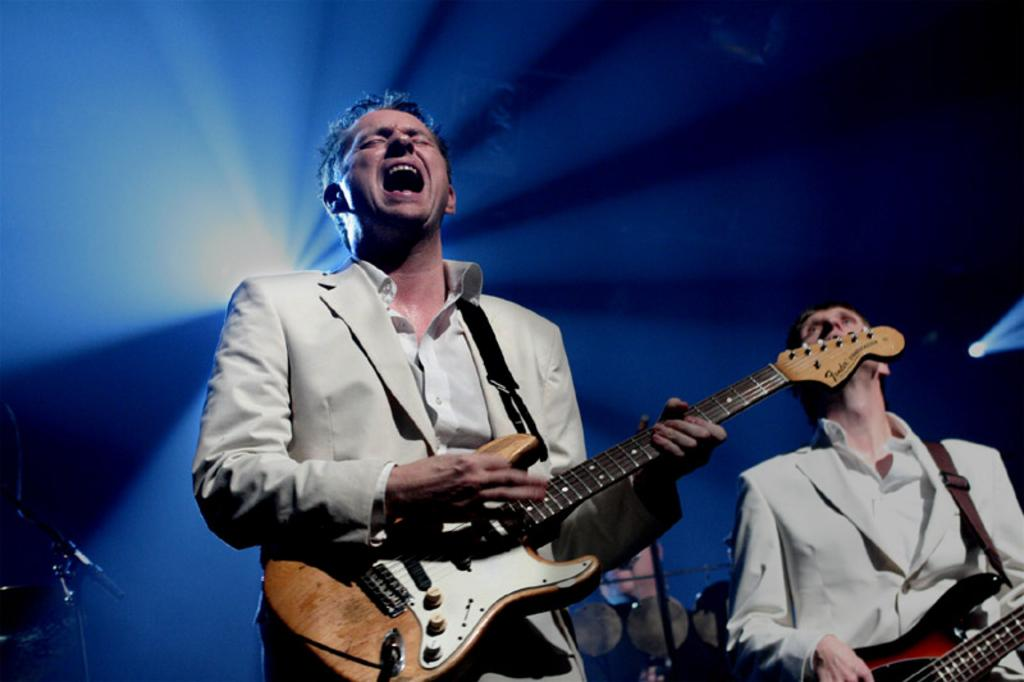What are the persons in the image doing? The persons in the image are standing and holding music instruments. What colors are the music instruments? The music instruments are in yellow and red colors. What can be seen in the background of the image? There is a blue color shed in the background of the image. What type of sweater is the achiever wearing in the image? There is no achiever or sweater present in the image. What type of apparel is the person wearing in the image? The provided facts do not mention the type of apparel the persons are wearing in the image. 